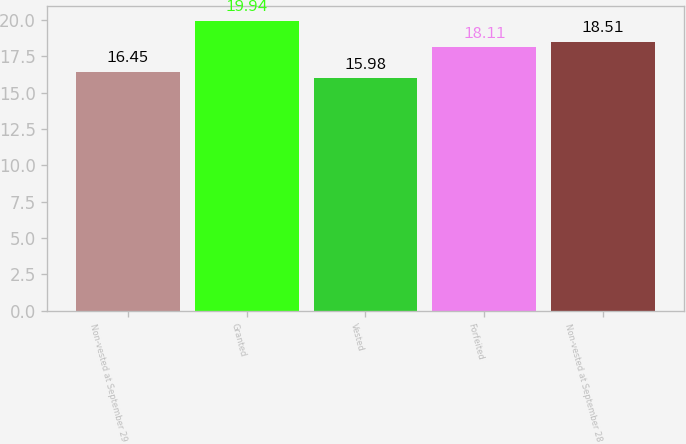<chart> <loc_0><loc_0><loc_500><loc_500><bar_chart><fcel>Non-vested at September 29<fcel>Granted<fcel>Vested<fcel>Forfeited<fcel>Non-vested at September 28<nl><fcel>16.45<fcel>19.94<fcel>15.98<fcel>18.11<fcel>18.51<nl></chart> 